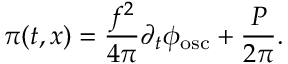<formula> <loc_0><loc_0><loc_500><loc_500>\pi ( t , x ) = \frac { f ^ { 2 } } { 4 { \pi } } { \partial } _ { t } { \phi } _ { o s c } + \frac { P } { 2 { \pi } } .</formula> 